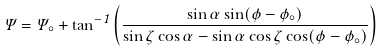Convert formula to latex. <formula><loc_0><loc_0><loc_500><loc_500>\Psi = \Psi _ { \circ } + \tan ^ { - 1 } \left ( \frac { \sin \alpha \sin ( \phi - \phi _ { \circ } ) } { \sin \zeta \cos \alpha - \sin \alpha \cos \zeta \cos ( \phi - \phi _ { \circ } ) } \right )</formula> 